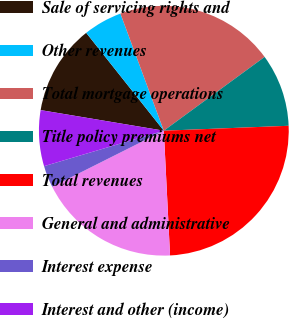Convert chart to OTSL. <chart><loc_0><loc_0><loc_500><loc_500><pie_chart><fcel>Sale of servicing rights and<fcel>Other revenues<fcel>Total mortgage operations<fcel>Title policy premiums net<fcel>Total revenues<fcel>General and administrative<fcel>Interest expense<fcel>Interest and other (income)<nl><fcel>11.69%<fcel>5.02%<fcel>20.59%<fcel>9.43%<fcel>24.83%<fcel>18.39%<fcel>2.82%<fcel>7.22%<nl></chart> 